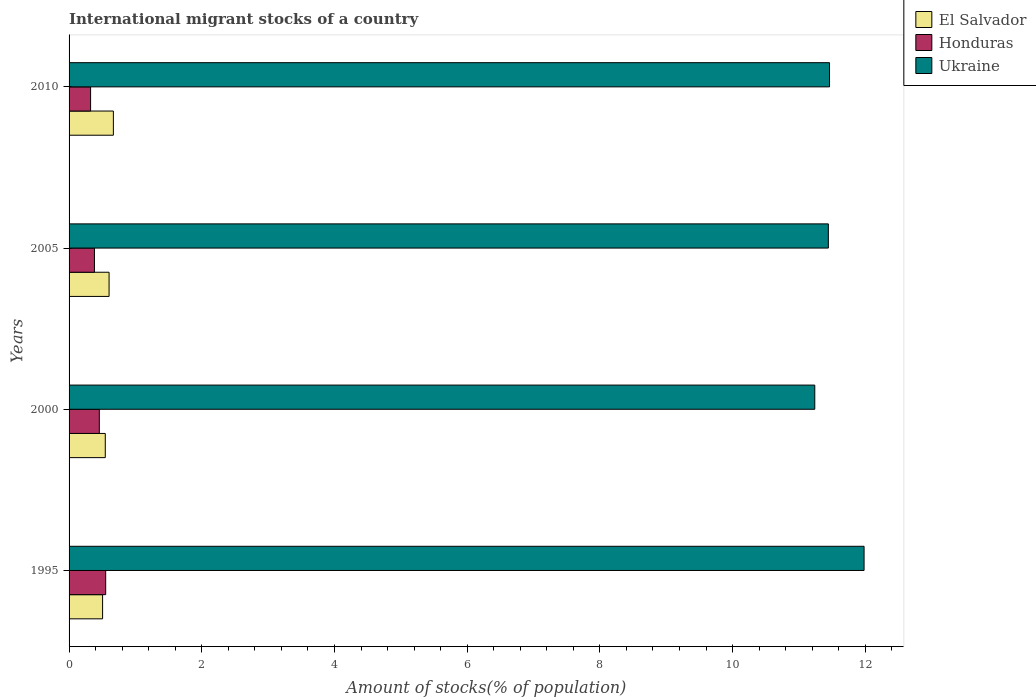Are the number of bars per tick equal to the number of legend labels?
Your answer should be very brief. Yes. In how many cases, is the number of bars for a given year not equal to the number of legend labels?
Ensure brevity in your answer.  0. What is the amount of stocks in in El Salvador in 1995?
Offer a very short reply. 0.51. Across all years, what is the maximum amount of stocks in in El Salvador?
Offer a terse response. 0.67. Across all years, what is the minimum amount of stocks in in El Salvador?
Your response must be concise. 0.51. What is the total amount of stocks in in Honduras in the graph?
Your response must be concise. 1.71. What is the difference between the amount of stocks in in Ukraine in 2005 and that in 2010?
Your response must be concise. -0.02. What is the difference between the amount of stocks in in Ukraine in 2010 and the amount of stocks in in El Salvador in 1995?
Keep it short and to the point. 10.96. What is the average amount of stocks in in El Salvador per year?
Offer a very short reply. 0.58. In the year 2000, what is the difference between the amount of stocks in in El Salvador and amount of stocks in in Honduras?
Give a very brief answer. 0.09. In how many years, is the amount of stocks in in Ukraine greater than 11.6 %?
Offer a terse response. 1. What is the ratio of the amount of stocks in in Ukraine in 2005 to that in 2010?
Your answer should be very brief. 1. Is the difference between the amount of stocks in in El Salvador in 1995 and 2000 greater than the difference between the amount of stocks in in Honduras in 1995 and 2000?
Make the answer very short. No. What is the difference between the highest and the second highest amount of stocks in in El Salvador?
Offer a terse response. 0.06. What is the difference between the highest and the lowest amount of stocks in in El Salvador?
Your response must be concise. 0.16. What does the 1st bar from the top in 2010 represents?
Offer a terse response. Ukraine. What does the 3rd bar from the bottom in 2010 represents?
Offer a very short reply. Ukraine. Is it the case that in every year, the sum of the amount of stocks in in Honduras and amount of stocks in in Ukraine is greater than the amount of stocks in in El Salvador?
Keep it short and to the point. Yes. How many years are there in the graph?
Offer a terse response. 4. Where does the legend appear in the graph?
Keep it short and to the point. Top right. What is the title of the graph?
Provide a succinct answer. International migrant stocks of a country. Does "High income" appear as one of the legend labels in the graph?
Provide a succinct answer. No. What is the label or title of the X-axis?
Give a very brief answer. Amount of stocks(% of population). What is the label or title of the Y-axis?
Your response must be concise. Years. What is the Amount of stocks(% of population) of El Salvador in 1995?
Provide a succinct answer. 0.51. What is the Amount of stocks(% of population) in Honduras in 1995?
Keep it short and to the point. 0.55. What is the Amount of stocks(% of population) of Ukraine in 1995?
Provide a short and direct response. 11.98. What is the Amount of stocks(% of population) of El Salvador in 2000?
Your answer should be compact. 0.55. What is the Amount of stocks(% of population) in Honduras in 2000?
Your answer should be compact. 0.46. What is the Amount of stocks(% of population) in Ukraine in 2000?
Give a very brief answer. 11.24. What is the Amount of stocks(% of population) in El Salvador in 2005?
Provide a succinct answer. 0.6. What is the Amount of stocks(% of population) in Honduras in 2005?
Your response must be concise. 0.38. What is the Amount of stocks(% of population) in Ukraine in 2005?
Your response must be concise. 11.44. What is the Amount of stocks(% of population) in El Salvador in 2010?
Your answer should be compact. 0.67. What is the Amount of stocks(% of population) in Honduras in 2010?
Offer a terse response. 0.32. What is the Amount of stocks(% of population) in Ukraine in 2010?
Ensure brevity in your answer.  11.46. Across all years, what is the maximum Amount of stocks(% of population) in El Salvador?
Offer a terse response. 0.67. Across all years, what is the maximum Amount of stocks(% of population) in Honduras?
Offer a very short reply. 0.55. Across all years, what is the maximum Amount of stocks(% of population) in Ukraine?
Offer a terse response. 11.98. Across all years, what is the minimum Amount of stocks(% of population) in El Salvador?
Provide a succinct answer. 0.51. Across all years, what is the minimum Amount of stocks(% of population) in Honduras?
Provide a short and direct response. 0.32. Across all years, what is the minimum Amount of stocks(% of population) in Ukraine?
Your answer should be compact. 11.24. What is the total Amount of stocks(% of population) in El Salvador in the graph?
Your response must be concise. 2.32. What is the total Amount of stocks(% of population) of Honduras in the graph?
Your response must be concise. 1.71. What is the total Amount of stocks(% of population) of Ukraine in the graph?
Give a very brief answer. 46.13. What is the difference between the Amount of stocks(% of population) in El Salvador in 1995 and that in 2000?
Make the answer very short. -0.04. What is the difference between the Amount of stocks(% of population) in Honduras in 1995 and that in 2000?
Keep it short and to the point. 0.1. What is the difference between the Amount of stocks(% of population) in Ukraine in 1995 and that in 2000?
Offer a terse response. 0.74. What is the difference between the Amount of stocks(% of population) of El Salvador in 1995 and that in 2005?
Ensure brevity in your answer.  -0.1. What is the difference between the Amount of stocks(% of population) in Honduras in 1995 and that in 2005?
Your response must be concise. 0.17. What is the difference between the Amount of stocks(% of population) in Ukraine in 1995 and that in 2005?
Your answer should be very brief. 0.54. What is the difference between the Amount of stocks(% of population) of El Salvador in 1995 and that in 2010?
Offer a terse response. -0.16. What is the difference between the Amount of stocks(% of population) in Honduras in 1995 and that in 2010?
Make the answer very short. 0.23. What is the difference between the Amount of stocks(% of population) of Ukraine in 1995 and that in 2010?
Make the answer very short. 0.52. What is the difference between the Amount of stocks(% of population) in El Salvador in 2000 and that in 2005?
Keep it short and to the point. -0.06. What is the difference between the Amount of stocks(% of population) in Honduras in 2000 and that in 2005?
Your answer should be very brief. 0.07. What is the difference between the Amount of stocks(% of population) of Ukraine in 2000 and that in 2005?
Your response must be concise. -0.2. What is the difference between the Amount of stocks(% of population) of El Salvador in 2000 and that in 2010?
Give a very brief answer. -0.12. What is the difference between the Amount of stocks(% of population) of Honduras in 2000 and that in 2010?
Make the answer very short. 0.13. What is the difference between the Amount of stocks(% of population) in Ukraine in 2000 and that in 2010?
Provide a succinct answer. -0.22. What is the difference between the Amount of stocks(% of population) of El Salvador in 2005 and that in 2010?
Your response must be concise. -0.06. What is the difference between the Amount of stocks(% of population) in Honduras in 2005 and that in 2010?
Your answer should be compact. 0.06. What is the difference between the Amount of stocks(% of population) in Ukraine in 2005 and that in 2010?
Make the answer very short. -0.02. What is the difference between the Amount of stocks(% of population) of El Salvador in 1995 and the Amount of stocks(% of population) of Honduras in 2000?
Provide a succinct answer. 0.05. What is the difference between the Amount of stocks(% of population) in El Salvador in 1995 and the Amount of stocks(% of population) in Ukraine in 2000?
Offer a terse response. -10.73. What is the difference between the Amount of stocks(% of population) of Honduras in 1995 and the Amount of stocks(% of population) of Ukraine in 2000?
Your answer should be compact. -10.69. What is the difference between the Amount of stocks(% of population) of El Salvador in 1995 and the Amount of stocks(% of population) of Honduras in 2005?
Offer a very short reply. 0.12. What is the difference between the Amount of stocks(% of population) of El Salvador in 1995 and the Amount of stocks(% of population) of Ukraine in 2005?
Make the answer very short. -10.94. What is the difference between the Amount of stocks(% of population) of Honduras in 1995 and the Amount of stocks(% of population) of Ukraine in 2005?
Give a very brief answer. -10.89. What is the difference between the Amount of stocks(% of population) of El Salvador in 1995 and the Amount of stocks(% of population) of Honduras in 2010?
Give a very brief answer. 0.18. What is the difference between the Amount of stocks(% of population) of El Salvador in 1995 and the Amount of stocks(% of population) of Ukraine in 2010?
Provide a succinct answer. -10.96. What is the difference between the Amount of stocks(% of population) of Honduras in 1995 and the Amount of stocks(% of population) of Ukraine in 2010?
Provide a short and direct response. -10.91. What is the difference between the Amount of stocks(% of population) of El Salvador in 2000 and the Amount of stocks(% of population) of Honduras in 2005?
Give a very brief answer. 0.16. What is the difference between the Amount of stocks(% of population) in El Salvador in 2000 and the Amount of stocks(% of population) in Ukraine in 2005?
Provide a short and direct response. -10.9. What is the difference between the Amount of stocks(% of population) in Honduras in 2000 and the Amount of stocks(% of population) in Ukraine in 2005?
Offer a very short reply. -10.99. What is the difference between the Amount of stocks(% of population) in El Salvador in 2000 and the Amount of stocks(% of population) in Honduras in 2010?
Offer a terse response. 0.22. What is the difference between the Amount of stocks(% of population) of El Salvador in 2000 and the Amount of stocks(% of population) of Ukraine in 2010?
Give a very brief answer. -10.92. What is the difference between the Amount of stocks(% of population) of Honduras in 2000 and the Amount of stocks(% of population) of Ukraine in 2010?
Give a very brief answer. -11.01. What is the difference between the Amount of stocks(% of population) in El Salvador in 2005 and the Amount of stocks(% of population) in Honduras in 2010?
Make the answer very short. 0.28. What is the difference between the Amount of stocks(% of population) of El Salvador in 2005 and the Amount of stocks(% of population) of Ukraine in 2010?
Your answer should be compact. -10.86. What is the difference between the Amount of stocks(% of population) in Honduras in 2005 and the Amount of stocks(% of population) in Ukraine in 2010?
Keep it short and to the point. -11.08. What is the average Amount of stocks(% of population) in El Salvador per year?
Provide a succinct answer. 0.58. What is the average Amount of stocks(% of population) in Honduras per year?
Keep it short and to the point. 0.43. What is the average Amount of stocks(% of population) of Ukraine per year?
Keep it short and to the point. 11.53. In the year 1995, what is the difference between the Amount of stocks(% of population) of El Salvador and Amount of stocks(% of population) of Honduras?
Your answer should be very brief. -0.05. In the year 1995, what is the difference between the Amount of stocks(% of population) in El Salvador and Amount of stocks(% of population) in Ukraine?
Your response must be concise. -11.48. In the year 1995, what is the difference between the Amount of stocks(% of population) of Honduras and Amount of stocks(% of population) of Ukraine?
Provide a short and direct response. -11.43. In the year 2000, what is the difference between the Amount of stocks(% of population) in El Salvador and Amount of stocks(% of population) in Honduras?
Offer a very short reply. 0.09. In the year 2000, what is the difference between the Amount of stocks(% of population) in El Salvador and Amount of stocks(% of population) in Ukraine?
Make the answer very short. -10.69. In the year 2000, what is the difference between the Amount of stocks(% of population) of Honduras and Amount of stocks(% of population) of Ukraine?
Offer a very short reply. -10.78. In the year 2005, what is the difference between the Amount of stocks(% of population) of El Salvador and Amount of stocks(% of population) of Honduras?
Keep it short and to the point. 0.22. In the year 2005, what is the difference between the Amount of stocks(% of population) in El Salvador and Amount of stocks(% of population) in Ukraine?
Your answer should be very brief. -10.84. In the year 2005, what is the difference between the Amount of stocks(% of population) in Honduras and Amount of stocks(% of population) in Ukraine?
Your response must be concise. -11.06. In the year 2010, what is the difference between the Amount of stocks(% of population) in El Salvador and Amount of stocks(% of population) in Honduras?
Offer a terse response. 0.34. In the year 2010, what is the difference between the Amount of stocks(% of population) of El Salvador and Amount of stocks(% of population) of Ukraine?
Provide a succinct answer. -10.79. In the year 2010, what is the difference between the Amount of stocks(% of population) in Honduras and Amount of stocks(% of population) in Ukraine?
Provide a short and direct response. -11.14. What is the ratio of the Amount of stocks(% of population) of El Salvador in 1995 to that in 2000?
Your answer should be compact. 0.93. What is the ratio of the Amount of stocks(% of population) of Honduras in 1995 to that in 2000?
Ensure brevity in your answer.  1.21. What is the ratio of the Amount of stocks(% of population) of Ukraine in 1995 to that in 2000?
Offer a very short reply. 1.07. What is the ratio of the Amount of stocks(% of population) of El Salvador in 1995 to that in 2005?
Your response must be concise. 0.84. What is the ratio of the Amount of stocks(% of population) of Honduras in 1995 to that in 2005?
Your answer should be very brief. 1.44. What is the ratio of the Amount of stocks(% of population) in Ukraine in 1995 to that in 2005?
Make the answer very short. 1.05. What is the ratio of the Amount of stocks(% of population) in El Salvador in 1995 to that in 2010?
Give a very brief answer. 0.76. What is the ratio of the Amount of stocks(% of population) of Honduras in 1995 to that in 2010?
Make the answer very short. 1.7. What is the ratio of the Amount of stocks(% of population) in Ukraine in 1995 to that in 2010?
Make the answer very short. 1.05. What is the ratio of the Amount of stocks(% of population) in El Salvador in 2000 to that in 2005?
Keep it short and to the point. 0.9. What is the ratio of the Amount of stocks(% of population) of Honduras in 2000 to that in 2005?
Your answer should be very brief. 1.19. What is the ratio of the Amount of stocks(% of population) in Ukraine in 2000 to that in 2005?
Ensure brevity in your answer.  0.98. What is the ratio of the Amount of stocks(% of population) of El Salvador in 2000 to that in 2010?
Ensure brevity in your answer.  0.82. What is the ratio of the Amount of stocks(% of population) of Honduras in 2000 to that in 2010?
Provide a succinct answer. 1.41. What is the ratio of the Amount of stocks(% of population) in Ukraine in 2000 to that in 2010?
Your answer should be very brief. 0.98. What is the ratio of the Amount of stocks(% of population) of El Salvador in 2005 to that in 2010?
Ensure brevity in your answer.  0.9. What is the ratio of the Amount of stocks(% of population) in Honduras in 2005 to that in 2010?
Keep it short and to the point. 1.18. What is the difference between the highest and the second highest Amount of stocks(% of population) of El Salvador?
Keep it short and to the point. 0.06. What is the difference between the highest and the second highest Amount of stocks(% of population) in Honduras?
Keep it short and to the point. 0.1. What is the difference between the highest and the second highest Amount of stocks(% of population) in Ukraine?
Offer a very short reply. 0.52. What is the difference between the highest and the lowest Amount of stocks(% of population) in El Salvador?
Your response must be concise. 0.16. What is the difference between the highest and the lowest Amount of stocks(% of population) in Honduras?
Ensure brevity in your answer.  0.23. What is the difference between the highest and the lowest Amount of stocks(% of population) of Ukraine?
Your response must be concise. 0.74. 